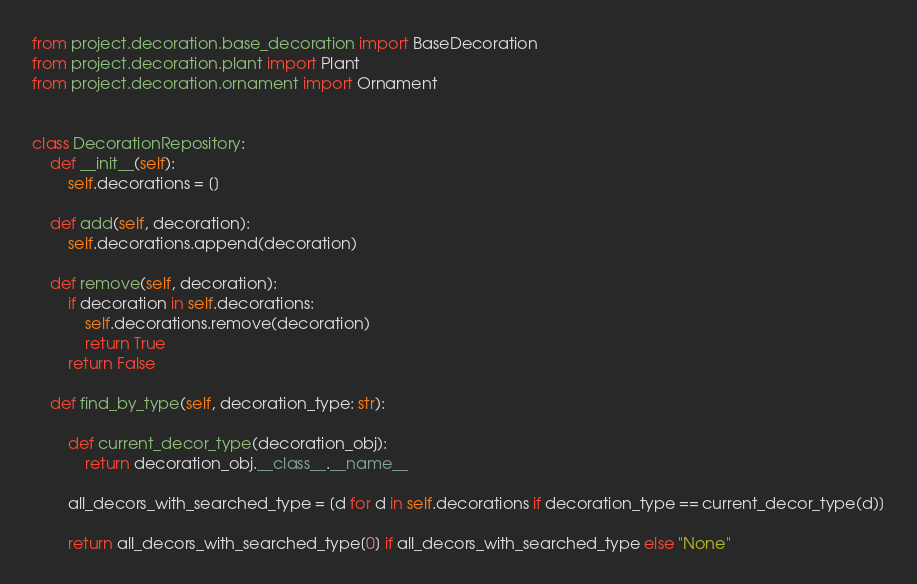<code> <loc_0><loc_0><loc_500><loc_500><_Python_>from project.decoration.base_decoration import BaseDecoration
from project.decoration.plant import Plant
from project.decoration.ornament import Ornament


class DecorationRepository:
    def __init__(self):
        self.decorations = []

    def add(self, decoration):
        self.decorations.append(decoration)

    def remove(self, decoration):
        if decoration in self.decorations:
            self.decorations.remove(decoration)
            return True
        return False

    def find_by_type(self, decoration_type: str):

        def current_decor_type(decoration_obj):
            return decoration_obj.__class__.__name__

        all_decors_with_searched_type = [d for d in self.decorations if decoration_type == current_decor_type(d)]

        return all_decors_with_searched_type[0] if all_decors_with_searched_type else "None"
</code> 